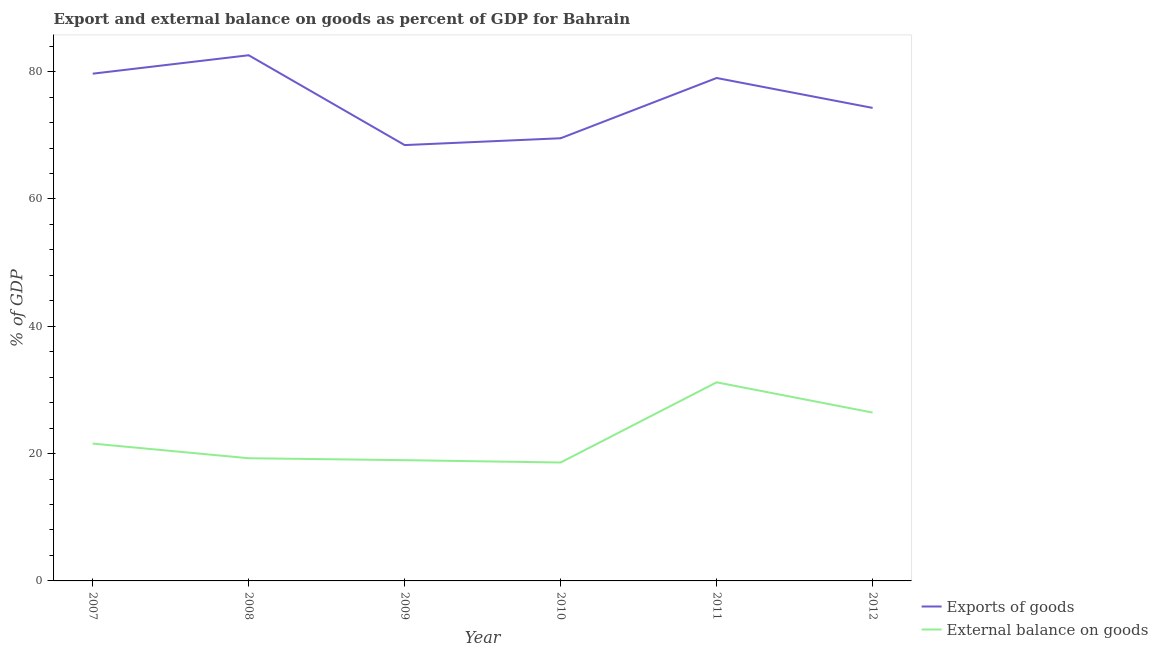Is the number of lines equal to the number of legend labels?
Keep it short and to the point. Yes. What is the external balance on goods as percentage of gdp in 2012?
Offer a very short reply. 26.45. Across all years, what is the maximum export of goods as percentage of gdp?
Offer a very short reply. 82.58. Across all years, what is the minimum export of goods as percentage of gdp?
Your response must be concise. 68.47. In which year was the export of goods as percentage of gdp maximum?
Your answer should be very brief. 2008. In which year was the export of goods as percentage of gdp minimum?
Your answer should be very brief. 2009. What is the total external balance on goods as percentage of gdp in the graph?
Offer a terse response. 136.06. What is the difference between the export of goods as percentage of gdp in 2007 and that in 2012?
Offer a terse response. 5.38. What is the difference between the external balance on goods as percentage of gdp in 2008 and the export of goods as percentage of gdp in 2007?
Your answer should be very brief. -60.41. What is the average external balance on goods as percentage of gdp per year?
Give a very brief answer. 22.68. In the year 2007, what is the difference between the export of goods as percentage of gdp and external balance on goods as percentage of gdp?
Provide a succinct answer. 58.11. What is the ratio of the export of goods as percentage of gdp in 2007 to that in 2008?
Provide a succinct answer. 0.96. Is the difference between the export of goods as percentage of gdp in 2009 and 2010 greater than the difference between the external balance on goods as percentage of gdp in 2009 and 2010?
Your response must be concise. No. What is the difference between the highest and the second highest external balance on goods as percentage of gdp?
Offer a very short reply. 4.75. What is the difference between the highest and the lowest export of goods as percentage of gdp?
Keep it short and to the point. 14.11. In how many years, is the export of goods as percentage of gdp greater than the average export of goods as percentage of gdp taken over all years?
Provide a succinct answer. 3. Is the export of goods as percentage of gdp strictly greater than the external balance on goods as percentage of gdp over the years?
Offer a terse response. Yes. Is the external balance on goods as percentage of gdp strictly less than the export of goods as percentage of gdp over the years?
Offer a very short reply. Yes. How many lines are there?
Offer a very short reply. 2. Are the values on the major ticks of Y-axis written in scientific E-notation?
Provide a short and direct response. No. Does the graph contain any zero values?
Your answer should be compact. No. Does the graph contain grids?
Your answer should be compact. No. How many legend labels are there?
Give a very brief answer. 2. What is the title of the graph?
Your answer should be compact. Export and external balance on goods as percent of GDP for Bahrain. Does "Banks" appear as one of the legend labels in the graph?
Ensure brevity in your answer.  No. What is the label or title of the Y-axis?
Offer a terse response. % of GDP. What is the % of GDP of Exports of goods in 2007?
Offer a very short reply. 79.68. What is the % of GDP of External balance on goods in 2007?
Provide a short and direct response. 21.57. What is the % of GDP of Exports of goods in 2008?
Make the answer very short. 82.58. What is the % of GDP of External balance on goods in 2008?
Provide a short and direct response. 19.27. What is the % of GDP of Exports of goods in 2009?
Give a very brief answer. 68.47. What is the % of GDP in External balance on goods in 2009?
Make the answer very short. 18.97. What is the % of GDP in Exports of goods in 2010?
Keep it short and to the point. 69.54. What is the % of GDP in External balance on goods in 2010?
Ensure brevity in your answer.  18.6. What is the % of GDP of Exports of goods in 2011?
Give a very brief answer. 79. What is the % of GDP of External balance on goods in 2011?
Provide a short and direct response. 31.2. What is the % of GDP of Exports of goods in 2012?
Your answer should be very brief. 74.3. What is the % of GDP in External balance on goods in 2012?
Your answer should be very brief. 26.45. Across all years, what is the maximum % of GDP of Exports of goods?
Your response must be concise. 82.58. Across all years, what is the maximum % of GDP in External balance on goods?
Offer a terse response. 31.2. Across all years, what is the minimum % of GDP of Exports of goods?
Offer a very short reply. 68.47. Across all years, what is the minimum % of GDP of External balance on goods?
Give a very brief answer. 18.6. What is the total % of GDP in Exports of goods in the graph?
Make the answer very short. 453.57. What is the total % of GDP of External balance on goods in the graph?
Provide a succinct answer. 136.06. What is the difference between the % of GDP of Exports of goods in 2007 and that in 2008?
Give a very brief answer. -2.9. What is the difference between the % of GDP of External balance on goods in 2007 and that in 2008?
Give a very brief answer. 2.3. What is the difference between the % of GDP in Exports of goods in 2007 and that in 2009?
Your response must be concise. 11.21. What is the difference between the % of GDP in External balance on goods in 2007 and that in 2009?
Provide a succinct answer. 2.61. What is the difference between the % of GDP in Exports of goods in 2007 and that in 2010?
Offer a very short reply. 10.14. What is the difference between the % of GDP in External balance on goods in 2007 and that in 2010?
Provide a succinct answer. 2.97. What is the difference between the % of GDP of Exports of goods in 2007 and that in 2011?
Ensure brevity in your answer.  0.68. What is the difference between the % of GDP of External balance on goods in 2007 and that in 2011?
Your response must be concise. -9.62. What is the difference between the % of GDP of Exports of goods in 2007 and that in 2012?
Keep it short and to the point. 5.38. What is the difference between the % of GDP in External balance on goods in 2007 and that in 2012?
Make the answer very short. -4.87. What is the difference between the % of GDP in Exports of goods in 2008 and that in 2009?
Your response must be concise. 14.11. What is the difference between the % of GDP of External balance on goods in 2008 and that in 2009?
Your response must be concise. 0.3. What is the difference between the % of GDP of Exports of goods in 2008 and that in 2010?
Your answer should be compact. 13.04. What is the difference between the % of GDP in External balance on goods in 2008 and that in 2010?
Make the answer very short. 0.67. What is the difference between the % of GDP of Exports of goods in 2008 and that in 2011?
Your answer should be very brief. 3.58. What is the difference between the % of GDP in External balance on goods in 2008 and that in 2011?
Your answer should be very brief. -11.93. What is the difference between the % of GDP in Exports of goods in 2008 and that in 2012?
Keep it short and to the point. 8.27. What is the difference between the % of GDP in External balance on goods in 2008 and that in 2012?
Offer a terse response. -7.17. What is the difference between the % of GDP of Exports of goods in 2009 and that in 2010?
Give a very brief answer. -1.07. What is the difference between the % of GDP of External balance on goods in 2009 and that in 2010?
Keep it short and to the point. 0.37. What is the difference between the % of GDP of Exports of goods in 2009 and that in 2011?
Offer a terse response. -10.54. What is the difference between the % of GDP of External balance on goods in 2009 and that in 2011?
Your response must be concise. -12.23. What is the difference between the % of GDP of Exports of goods in 2009 and that in 2012?
Your response must be concise. -5.84. What is the difference between the % of GDP in External balance on goods in 2009 and that in 2012?
Keep it short and to the point. -7.48. What is the difference between the % of GDP in Exports of goods in 2010 and that in 2011?
Give a very brief answer. -9.46. What is the difference between the % of GDP of External balance on goods in 2010 and that in 2011?
Provide a succinct answer. -12.6. What is the difference between the % of GDP in Exports of goods in 2010 and that in 2012?
Provide a succinct answer. -4.77. What is the difference between the % of GDP in External balance on goods in 2010 and that in 2012?
Your answer should be very brief. -7.84. What is the difference between the % of GDP of Exports of goods in 2011 and that in 2012?
Your response must be concise. 4.7. What is the difference between the % of GDP in External balance on goods in 2011 and that in 2012?
Offer a terse response. 4.75. What is the difference between the % of GDP in Exports of goods in 2007 and the % of GDP in External balance on goods in 2008?
Give a very brief answer. 60.41. What is the difference between the % of GDP in Exports of goods in 2007 and the % of GDP in External balance on goods in 2009?
Your answer should be compact. 60.71. What is the difference between the % of GDP of Exports of goods in 2007 and the % of GDP of External balance on goods in 2010?
Offer a terse response. 61.08. What is the difference between the % of GDP in Exports of goods in 2007 and the % of GDP in External balance on goods in 2011?
Keep it short and to the point. 48.48. What is the difference between the % of GDP in Exports of goods in 2007 and the % of GDP in External balance on goods in 2012?
Your answer should be very brief. 53.23. What is the difference between the % of GDP of Exports of goods in 2008 and the % of GDP of External balance on goods in 2009?
Give a very brief answer. 63.61. What is the difference between the % of GDP in Exports of goods in 2008 and the % of GDP in External balance on goods in 2010?
Provide a succinct answer. 63.98. What is the difference between the % of GDP in Exports of goods in 2008 and the % of GDP in External balance on goods in 2011?
Make the answer very short. 51.38. What is the difference between the % of GDP of Exports of goods in 2008 and the % of GDP of External balance on goods in 2012?
Offer a very short reply. 56.13. What is the difference between the % of GDP in Exports of goods in 2009 and the % of GDP in External balance on goods in 2010?
Provide a succinct answer. 49.86. What is the difference between the % of GDP in Exports of goods in 2009 and the % of GDP in External balance on goods in 2011?
Provide a succinct answer. 37.27. What is the difference between the % of GDP of Exports of goods in 2009 and the % of GDP of External balance on goods in 2012?
Your answer should be compact. 42.02. What is the difference between the % of GDP in Exports of goods in 2010 and the % of GDP in External balance on goods in 2011?
Provide a succinct answer. 38.34. What is the difference between the % of GDP of Exports of goods in 2010 and the % of GDP of External balance on goods in 2012?
Provide a short and direct response. 43.09. What is the difference between the % of GDP of Exports of goods in 2011 and the % of GDP of External balance on goods in 2012?
Your answer should be compact. 52.56. What is the average % of GDP of Exports of goods per year?
Your response must be concise. 75.59. What is the average % of GDP of External balance on goods per year?
Your answer should be very brief. 22.68. In the year 2007, what is the difference between the % of GDP in Exports of goods and % of GDP in External balance on goods?
Keep it short and to the point. 58.11. In the year 2008, what is the difference between the % of GDP in Exports of goods and % of GDP in External balance on goods?
Offer a terse response. 63.31. In the year 2009, what is the difference between the % of GDP in Exports of goods and % of GDP in External balance on goods?
Offer a terse response. 49.5. In the year 2010, what is the difference between the % of GDP of Exports of goods and % of GDP of External balance on goods?
Your answer should be very brief. 50.94. In the year 2011, what is the difference between the % of GDP of Exports of goods and % of GDP of External balance on goods?
Ensure brevity in your answer.  47.8. In the year 2012, what is the difference between the % of GDP in Exports of goods and % of GDP in External balance on goods?
Ensure brevity in your answer.  47.86. What is the ratio of the % of GDP of Exports of goods in 2007 to that in 2008?
Your response must be concise. 0.96. What is the ratio of the % of GDP of External balance on goods in 2007 to that in 2008?
Provide a short and direct response. 1.12. What is the ratio of the % of GDP in Exports of goods in 2007 to that in 2009?
Offer a terse response. 1.16. What is the ratio of the % of GDP of External balance on goods in 2007 to that in 2009?
Keep it short and to the point. 1.14. What is the ratio of the % of GDP in Exports of goods in 2007 to that in 2010?
Your answer should be compact. 1.15. What is the ratio of the % of GDP in External balance on goods in 2007 to that in 2010?
Provide a short and direct response. 1.16. What is the ratio of the % of GDP in Exports of goods in 2007 to that in 2011?
Keep it short and to the point. 1.01. What is the ratio of the % of GDP of External balance on goods in 2007 to that in 2011?
Your response must be concise. 0.69. What is the ratio of the % of GDP of Exports of goods in 2007 to that in 2012?
Make the answer very short. 1.07. What is the ratio of the % of GDP in External balance on goods in 2007 to that in 2012?
Your response must be concise. 0.82. What is the ratio of the % of GDP in Exports of goods in 2008 to that in 2009?
Ensure brevity in your answer.  1.21. What is the ratio of the % of GDP in External balance on goods in 2008 to that in 2009?
Ensure brevity in your answer.  1.02. What is the ratio of the % of GDP in Exports of goods in 2008 to that in 2010?
Keep it short and to the point. 1.19. What is the ratio of the % of GDP of External balance on goods in 2008 to that in 2010?
Make the answer very short. 1.04. What is the ratio of the % of GDP in Exports of goods in 2008 to that in 2011?
Give a very brief answer. 1.05. What is the ratio of the % of GDP of External balance on goods in 2008 to that in 2011?
Make the answer very short. 0.62. What is the ratio of the % of GDP in Exports of goods in 2008 to that in 2012?
Offer a very short reply. 1.11. What is the ratio of the % of GDP in External balance on goods in 2008 to that in 2012?
Give a very brief answer. 0.73. What is the ratio of the % of GDP in Exports of goods in 2009 to that in 2010?
Your response must be concise. 0.98. What is the ratio of the % of GDP of External balance on goods in 2009 to that in 2010?
Offer a very short reply. 1.02. What is the ratio of the % of GDP of Exports of goods in 2009 to that in 2011?
Offer a terse response. 0.87. What is the ratio of the % of GDP in External balance on goods in 2009 to that in 2011?
Your answer should be very brief. 0.61. What is the ratio of the % of GDP of Exports of goods in 2009 to that in 2012?
Your answer should be compact. 0.92. What is the ratio of the % of GDP of External balance on goods in 2009 to that in 2012?
Make the answer very short. 0.72. What is the ratio of the % of GDP of Exports of goods in 2010 to that in 2011?
Provide a short and direct response. 0.88. What is the ratio of the % of GDP of External balance on goods in 2010 to that in 2011?
Your answer should be very brief. 0.6. What is the ratio of the % of GDP of Exports of goods in 2010 to that in 2012?
Your answer should be very brief. 0.94. What is the ratio of the % of GDP of External balance on goods in 2010 to that in 2012?
Provide a short and direct response. 0.7. What is the ratio of the % of GDP of Exports of goods in 2011 to that in 2012?
Keep it short and to the point. 1.06. What is the ratio of the % of GDP in External balance on goods in 2011 to that in 2012?
Your response must be concise. 1.18. What is the difference between the highest and the second highest % of GDP in Exports of goods?
Make the answer very short. 2.9. What is the difference between the highest and the second highest % of GDP in External balance on goods?
Provide a short and direct response. 4.75. What is the difference between the highest and the lowest % of GDP in Exports of goods?
Offer a very short reply. 14.11. What is the difference between the highest and the lowest % of GDP of External balance on goods?
Provide a short and direct response. 12.6. 